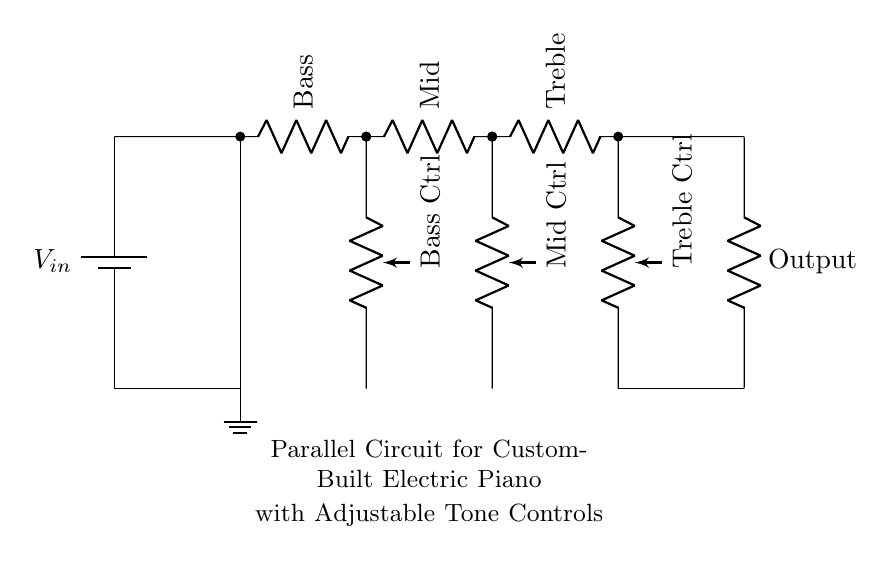What is the power supply voltage in the circuit? The power supply voltage is indicated on the battery symbol at the top left of the circuit diagram. It is labeled as "Vin," which represents the input voltage for the circuit.
Answer: Vin How many tone control resistors are present in the circuit? The circuit shows three tone control resistors labeled as Bass, Mid, and Treble. Each of these is connected in parallel, as indicated by their arrangement in the diagram.
Answer: Three What type of circuit is used for the tone controls? The tone controls are connected in a parallel configuration, as evidenced by each resistor having its own separate branch that connects back to the main circuit at the output.
Answer: Parallel Which component is used for adjusting the bass tone? The component specifically for adjusting the bass tone is labeled "Bass Ctrl," which is a potentiometer connected directly under the Bass resistor in the circuit.
Answer: Bass Ctrl What happens to the total resistance as more tone controls are added in parallel? When more tone controls (resistors) are added in parallel, the total resistance of the circuit decreases. This is due to the formula for total resistance in parallel circuits, which is lower than the smallest individual resistance.
Answer: Decreases How is the output connected to the tone controls? The output is connected to the end of the last tone control resistor (Treble), which indicates that the modified signal from all tone controls is directed to the output. This is a key feature of parallel circuits to ensure the signal passes through each tone control independently.
Answer: Through Treble 